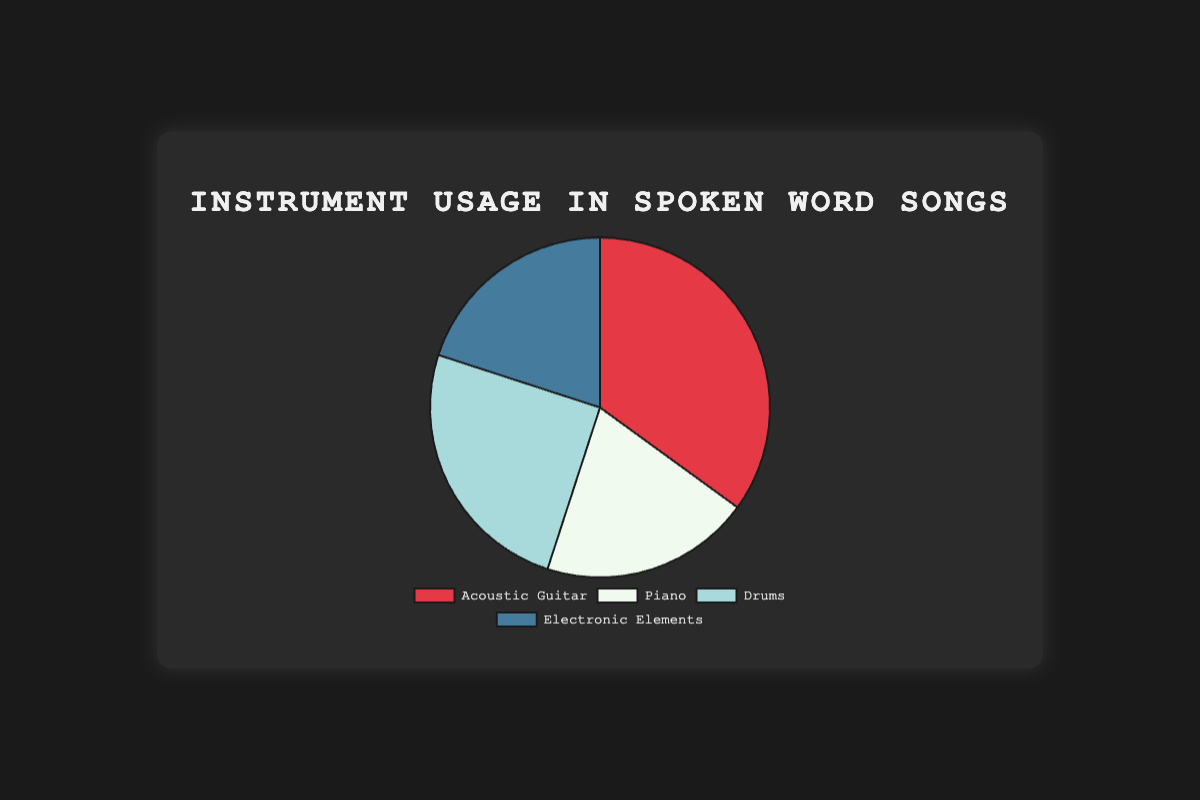How many instruments are used equally in songs? The percentages for Piano and Electronic Elements are both 20%.
Answer: 2 Which instrument is used the most in songs? The Acoustic Guitar has the highest percentage at 35%.
Answer: Acoustic Guitar What's the combined percentage of instruments other than Acoustic Guitar? Add the percentages of Piano (20%), Drums (25%), and Electronic Elements (20%): 20 + 25 + 20 = 65%
Answer: 65% Compare the usage of Acoustic Guitar and Drums. Which one is used more and by how much? The Acoustic Guitar is used more. Subtract the percentage of Drums (25%) from Acoustic Guitar (35%): 35 - 25 = 10%
Answer: Acoustic Guitar by 10% What is the total percentage of songs that use either Piano or Electronic Elements? Add the percentages of Piano (20%) and Electronic Elements (20%): 20 + 20 = 40%
Answer: 40% Is the usage of Drums more than the usage of Piano? The percentage of Drums (25%) is more than Piano (20%).
Answer: Yes Which segment on the pie chart is blue? The segment for Electronic Elements is blue.
Answer: Electronic Elements What's the percentage difference between the least and the most used instruments? Acoustic Guitar is the most used (35%) and Piano/Electronic Elements are the least used (20%). Subtract the least from the most: 35 - 20 = 15%
Answer: 15% If you were to take away the usage of Drums, what percentage of the pie chart would remain? Subtract the percentage of Drums (25%) from 100%: 100 - 25 = 75%
Answer: 75% What is the most common visual attribute associated with the Acoustic Guitar segment? The Acoustic Guitar segment is colored red.
Answer: Red 